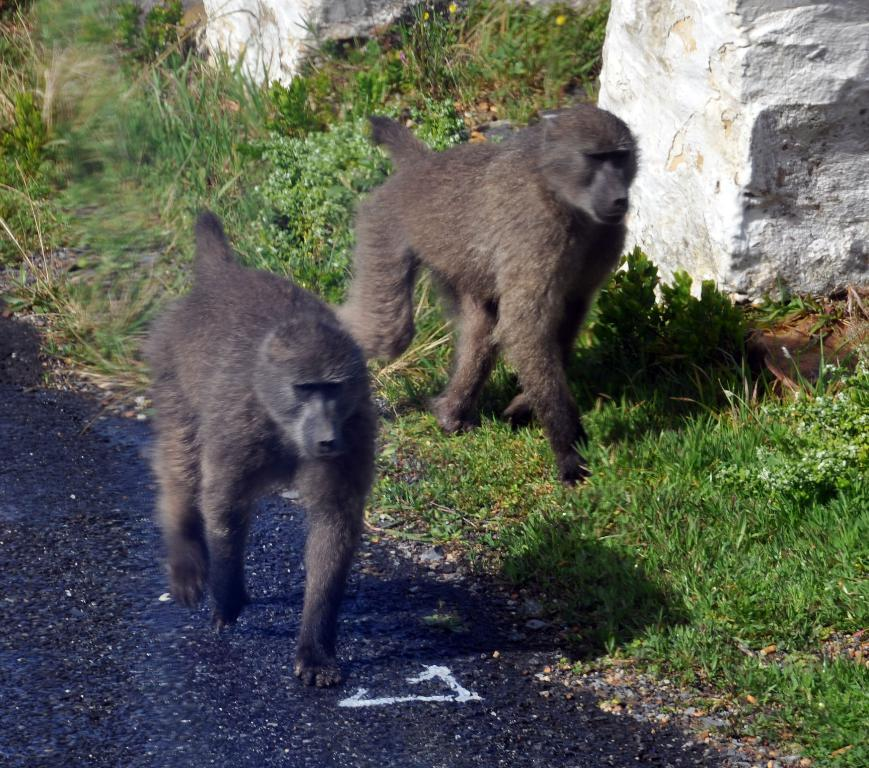What animals are present on the road in the image? There are baboons on the road in the image. What type of vegetation can be seen in the image? There is grass visible in the image. What other objects can be seen on the road? There are stones in the image. What type of pencil can be seen in the image? There is no pencil present in the image. 